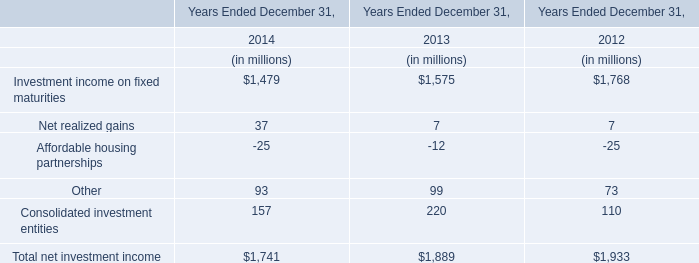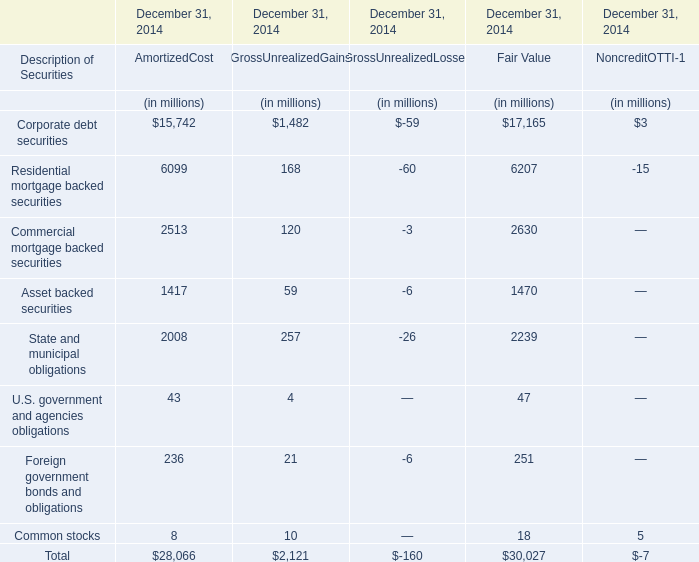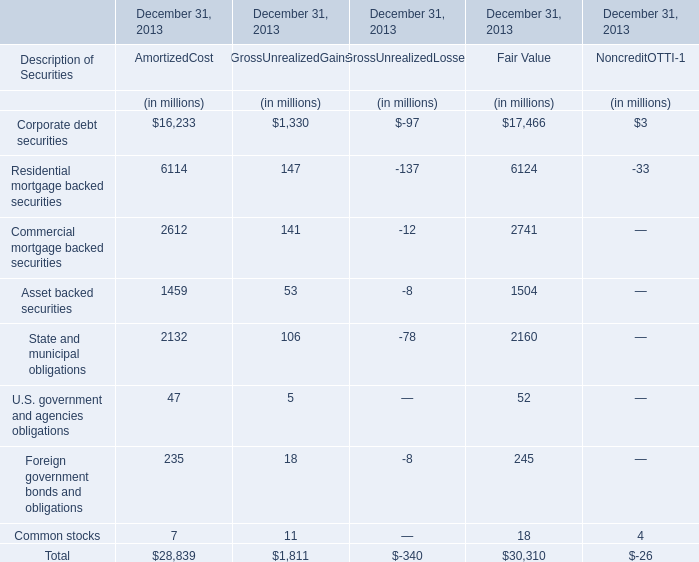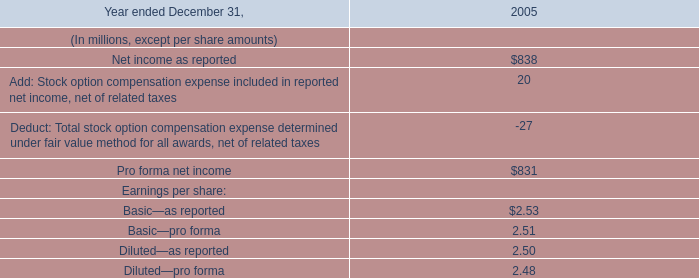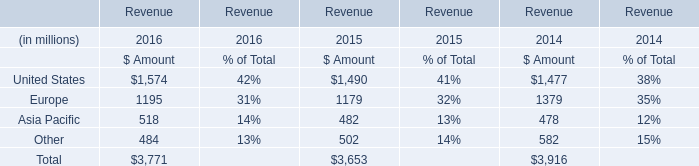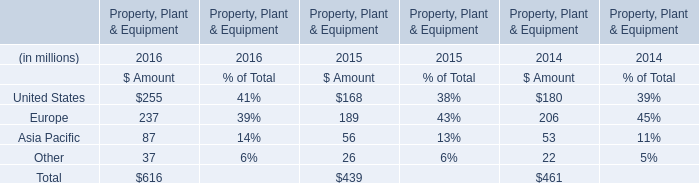In the year with the most Europe of Amount in Table 5, what is the growth rate of Asia Pacific in Table 4? 
Computations: ((518 - 482) / 482)
Answer: 0.07469. 